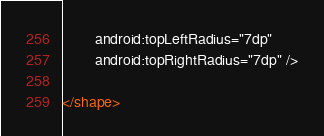<code> <loc_0><loc_0><loc_500><loc_500><_XML_>        android:topLeftRadius="7dp"
        android:topRightRadius="7dp" />

</shape> 
</code> 